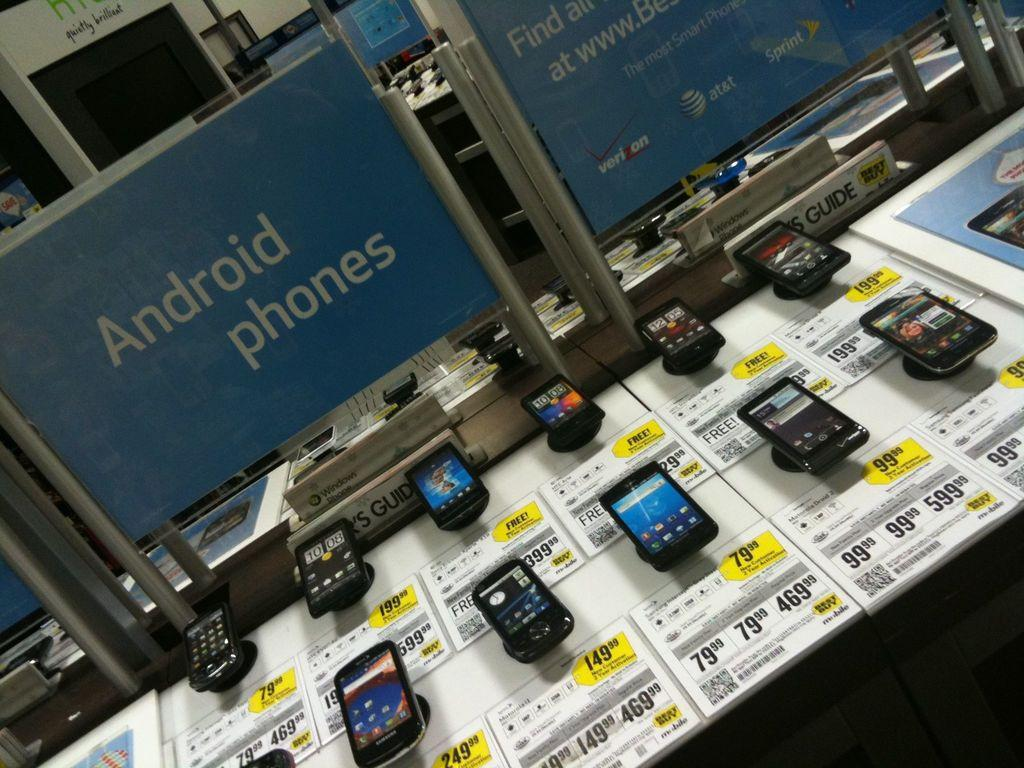Provide a one-sentence caption for the provided image. Several phones are displayed, one of which is selling for 149.998. 